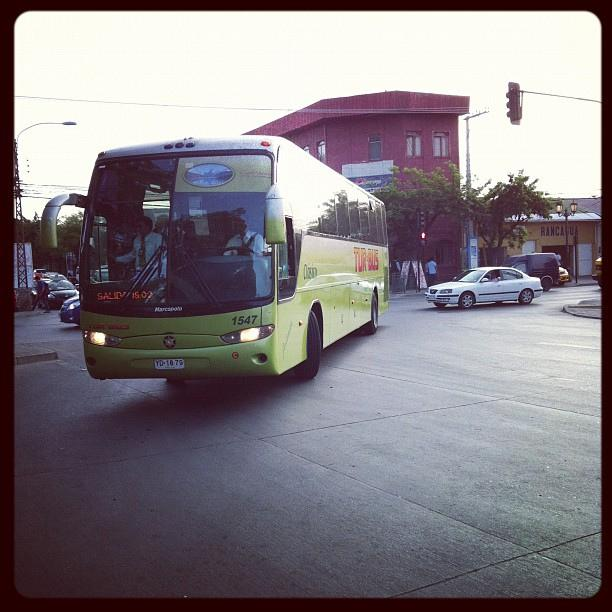What make of vehicle is following the bus?

Choices:
A) kia
B) mazda
C) nissan
D) hyundai hyundai 